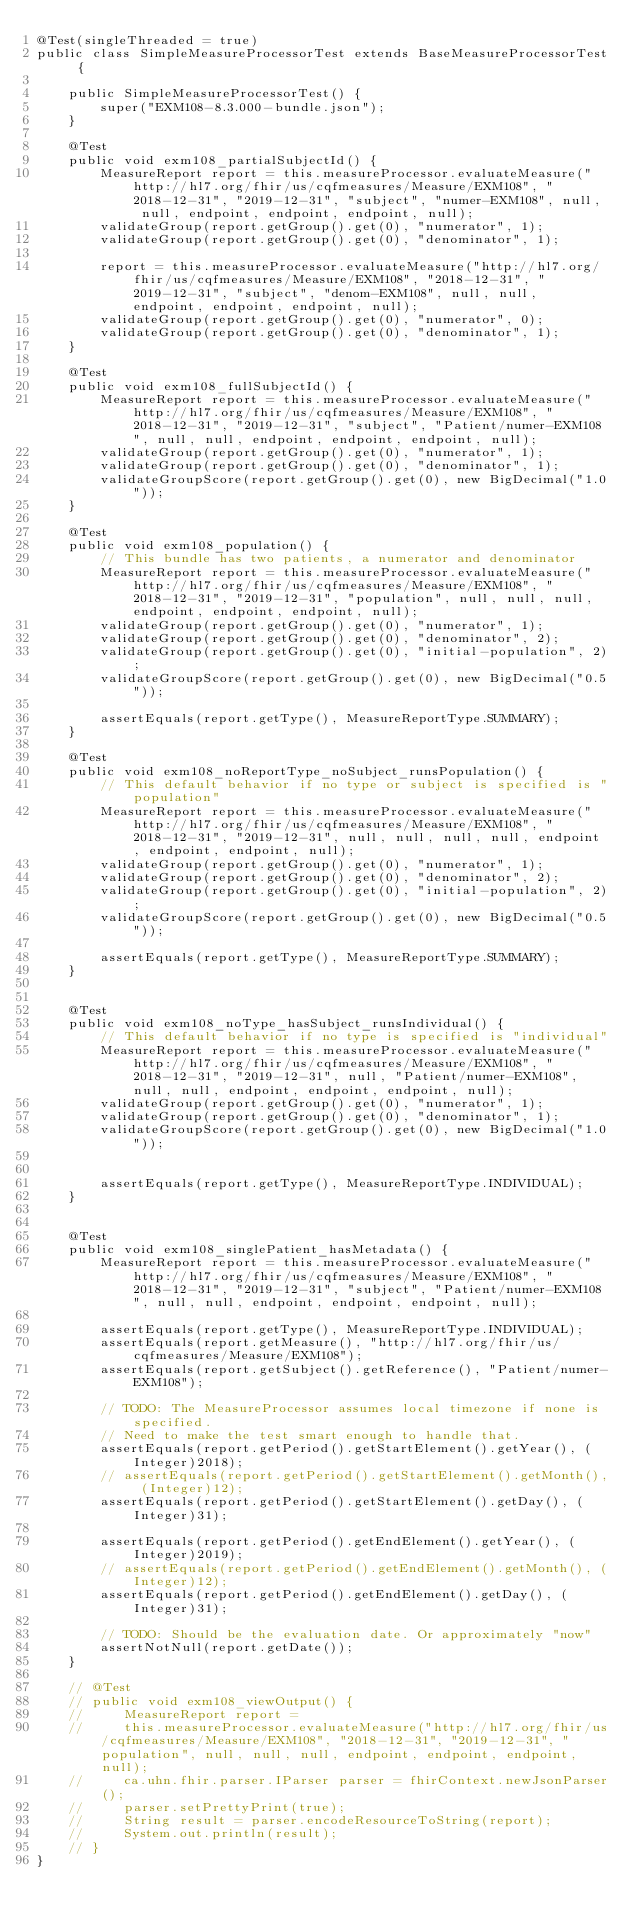<code> <loc_0><loc_0><loc_500><loc_500><_Java_>@Test(singleThreaded = true)
public class SimpleMeasureProcessorTest extends BaseMeasureProcessorTest {
    
    public SimpleMeasureProcessorTest() {
        super("EXM108-8.3.000-bundle.json");
    }

    @Test
    public void exm108_partialSubjectId() {
        MeasureReport report = this.measureProcessor.evaluateMeasure("http://hl7.org/fhir/us/cqfmeasures/Measure/EXM108", "2018-12-31", "2019-12-31", "subject", "numer-EXM108", null, null, endpoint, endpoint, endpoint, null);
        validateGroup(report.getGroup().get(0), "numerator", 1);
        validateGroup(report.getGroup().get(0), "denominator", 1);

        report = this.measureProcessor.evaluateMeasure("http://hl7.org/fhir/us/cqfmeasures/Measure/EXM108", "2018-12-31", "2019-12-31", "subject", "denom-EXM108", null, null, endpoint, endpoint, endpoint, null);
        validateGroup(report.getGroup().get(0), "numerator", 0);
        validateGroup(report.getGroup().get(0), "denominator", 1);
    }

    @Test
    public void exm108_fullSubjectId() {
        MeasureReport report = this.measureProcessor.evaluateMeasure("http://hl7.org/fhir/us/cqfmeasures/Measure/EXM108", "2018-12-31", "2019-12-31", "subject", "Patient/numer-EXM108", null, null, endpoint, endpoint, endpoint, null);
        validateGroup(report.getGroup().get(0), "numerator", 1);
        validateGroup(report.getGroup().get(0), "denominator", 1);
        validateGroupScore(report.getGroup().get(0), new BigDecimal("1.0"));
    }

    @Test
    public void exm108_population() {
        // This bundle has two patients, a numerator and denominator
        MeasureReport report = this.measureProcessor.evaluateMeasure("http://hl7.org/fhir/us/cqfmeasures/Measure/EXM108", "2018-12-31", "2019-12-31", "population", null, null, null, endpoint, endpoint, endpoint, null);
        validateGroup(report.getGroup().get(0), "numerator", 1);
        validateGroup(report.getGroup().get(0), "denominator", 2);
        validateGroup(report.getGroup().get(0), "initial-population", 2);
        validateGroupScore(report.getGroup().get(0), new BigDecimal("0.5"));

        assertEquals(report.getType(), MeasureReportType.SUMMARY);
    }

    @Test
    public void exm108_noReportType_noSubject_runsPopulation() {
        // This default behavior if no type or subject is specified is "population"
        MeasureReport report = this.measureProcessor.evaluateMeasure("http://hl7.org/fhir/us/cqfmeasures/Measure/EXM108", "2018-12-31", "2019-12-31", null, null, null, null, endpoint, endpoint, endpoint, null);
        validateGroup(report.getGroup().get(0), "numerator", 1);
        validateGroup(report.getGroup().get(0), "denominator", 2);
        validateGroup(report.getGroup().get(0), "initial-population", 2);
        validateGroupScore(report.getGroup().get(0), new BigDecimal("0.5"));

        assertEquals(report.getType(), MeasureReportType.SUMMARY);
    }


    @Test
    public void exm108_noType_hasSubject_runsIndividual() {
        // This default behavior if no type is specified is "individual"
        MeasureReport report = this.measureProcessor.evaluateMeasure("http://hl7.org/fhir/us/cqfmeasures/Measure/EXM108", "2018-12-31", "2019-12-31", null, "Patient/numer-EXM108", null, null, endpoint, endpoint, endpoint, null);
        validateGroup(report.getGroup().get(0), "numerator", 1);
        validateGroup(report.getGroup().get(0), "denominator", 1);
        validateGroupScore(report.getGroup().get(0), new BigDecimal("1.0"));


        assertEquals(report.getType(), MeasureReportType.INDIVIDUAL);
    }


    @Test
    public void exm108_singlePatient_hasMetadata() {
        MeasureReport report = this.measureProcessor.evaluateMeasure("http://hl7.org/fhir/us/cqfmeasures/Measure/EXM108", "2018-12-31", "2019-12-31", "subject", "Patient/numer-EXM108", null, null, endpoint, endpoint, endpoint, null);

        assertEquals(report.getType(), MeasureReportType.INDIVIDUAL);
        assertEquals(report.getMeasure(), "http://hl7.org/fhir/us/cqfmeasures/Measure/EXM108");
        assertEquals(report.getSubject().getReference(), "Patient/numer-EXM108");

        // TODO: The MeasureProcessor assumes local timezone if none is specified.
        // Need to make the test smart enough to handle that.
        assertEquals(report.getPeriod().getStartElement().getYear(), (Integer)2018);
        // assertEquals(report.getPeriod().getStartElement().getMonth(), (Integer)12);
        assertEquals(report.getPeriod().getStartElement().getDay(), (Integer)31);
     
        assertEquals(report.getPeriod().getEndElement().getYear(), (Integer)2019);
        // assertEquals(report.getPeriod().getEndElement().getMonth(), (Integer)12);
        assertEquals(report.getPeriod().getEndElement().getDay(), (Integer)31);

        // TODO: Should be the evaluation date. Or approximately "now"
        assertNotNull(report.getDate());
    }

    // @Test
    // public void exm108_viewOutput() {
    //     MeasureReport report = 
    //     this.measureProcessor.evaluateMeasure("http://hl7.org/fhir/us/cqfmeasures/Measure/EXM108", "2018-12-31", "2019-12-31", "population", null, null, null, endpoint, endpoint, endpoint, null);
    //     ca.uhn.fhir.parser.IParser parser = fhirContext.newJsonParser();
    //     parser.setPrettyPrint(true);
    //     String result = parser.encodeResourceToString(report);
    //     System.out.println(result);
    // }
}
</code> 